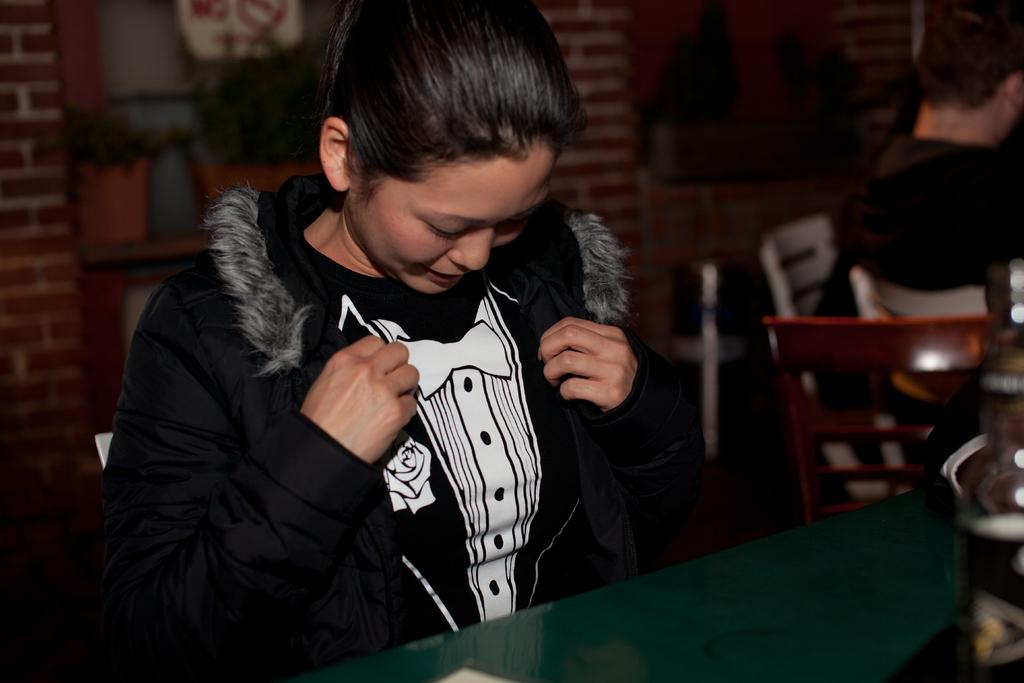Who is the main subject in the image? There is a girl in the image. What is the girl wearing? The girl is wearing a black jacket. What else can be seen in the image besides the girl? There are chairs in the image. What type of ship can be seen in the image? There is no ship present in the image; it features a girl wearing a black jacket and chairs. How many ducks are visible in the image? There are no ducks present in the image. 